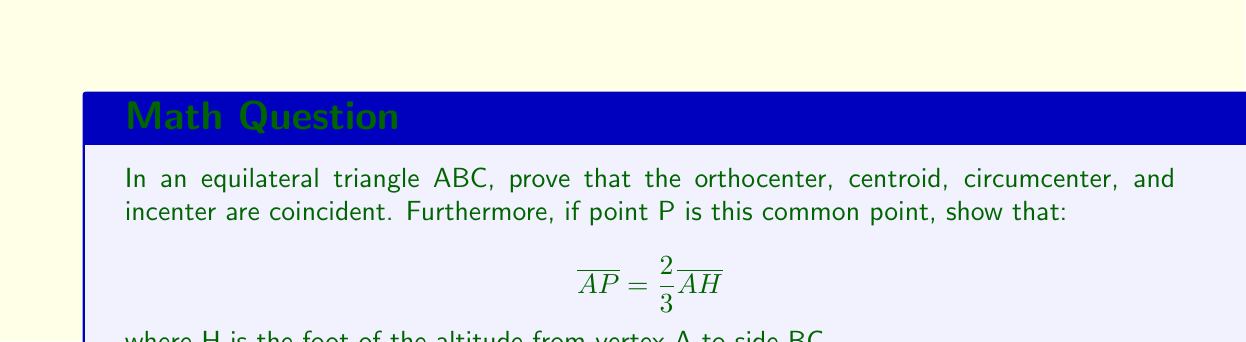Show me your answer to this math problem. Let's approach this proof step-by-step:

1) In an equilateral triangle, all sides are equal and all angles are 60°.

2) The orthocenter is the point where the three altitudes intersect. In an equilateral triangle, each altitude is also an angle bisector and a median.

3) The centroid is the point where the three medians intersect. As the altitudes are also medians in this case, the centroid coincides with the orthocenter.

4) The circumcenter is the point where the perpendicular bisectors of the sides intersect. In an equilateral triangle, these perpendicular bisectors are the same as the altitudes. Thus, the circumcenter coincides with the orthocenter and centroid.

5) The incenter is the point where the angle bisectors intersect. As mentioned, the altitudes are also angle bisectors in an equilateral triangle. Therefore, the incenter also coincides with the other centers.

Now, let's prove that $\overline{AP} = \frac{2}{3}\overline{AH}$:

6) In any triangle, the centroid divides each median in the ratio 2:1, with the longer segment closer to the vertex.

7) Since P is the centroid and AH is a median (as well as an altitude), we can conclude that:

   $$\overline{AP} : \overline{PH} = 2 : 1$$

8) This means that $\overline{AP} = \frac{2}{3}\overline{AH}$, as $\overline{AP}$ is 2 parts and $\overline{AH}$ is 3 parts of the same line segment.

[asy]
import geometry;

pair A = (0,2*sqrt(3)), B = (-1,0), C = (1,0);
pair H = (0,0);
pair P = (0,2*sqrt(3)/3);

draw(A--B--C--cycle);
draw(A--H);

dot("A", A, N);
dot("B", B, SW);
dot("C", C, SE);
dot("H", H, S);
dot("P", P, E);

label("$\frac{2}{3}$", (P+A)/2, E);
label("$\frac{1}{3}$", (P+H)/2, E);
[/asy]
Answer: $\overline{AP} = \frac{2}{3}\overline{AH}$ 